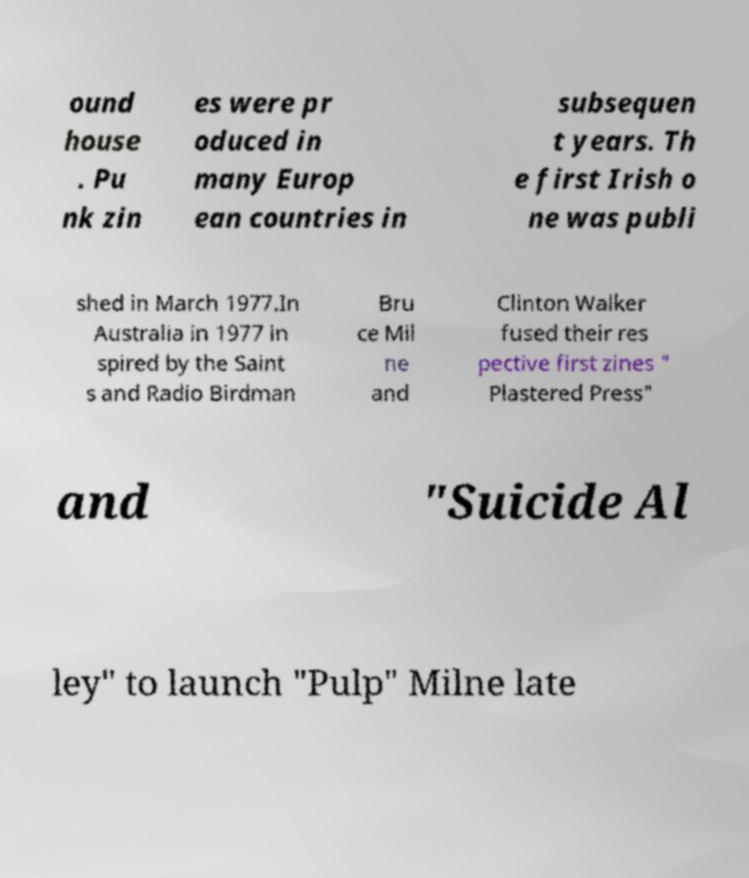Can you read and provide the text displayed in the image?This photo seems to have some interesting text. Can you extract and type it out for me? ound house . Pu nk zin es were pr oduced in many Europ ean countries in subsequen t years. Th e first Irish o ne was publi shed in March 1977.In Australia in 1977 in spired by the Saint s and Radio Birdman Bru ce Mil ne and Clinton Walker fused their res pective first zines " Plastered Press" and "Suicide Al ley" to launch "Pulp" Milne late 